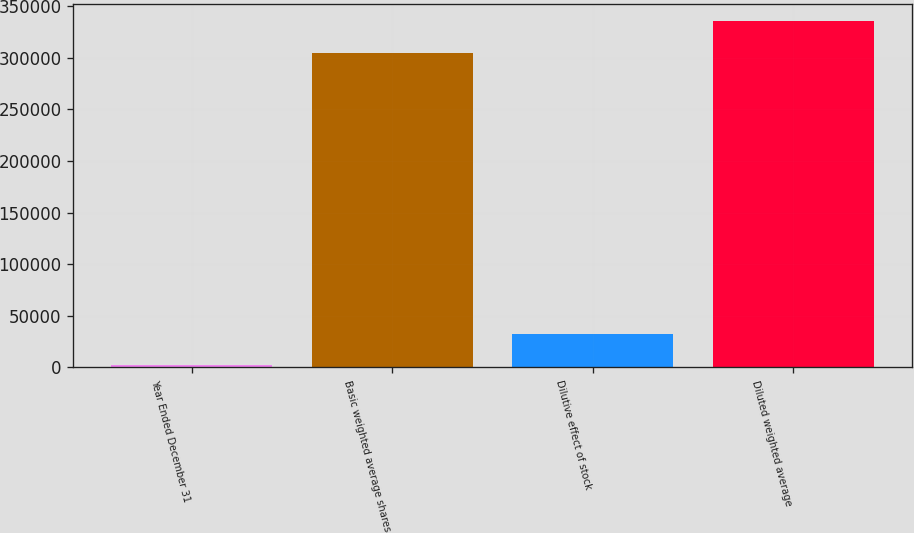Convert chart. <chart><loc_0><loc_0><loc_500><loc_500><bar_chart><fcel>Year Ended December 31<fcel>Basic weighted average shares<fcel>Dilutive effect of stock<fcel>Diluted weighted average<nl><fcel>2016<fcel>304707<fcel>32853.1<fcel>335544<nl></chart> 